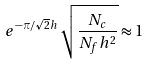<formula> <loc_0><loc_0><loc_500><loc_500>e ^ { - \pi / \sqrt { 2 } h } \, \sqrt { \frac { N _ { c } } { N _ { f } h ^ { 2 } } } \approx 1</formula> 